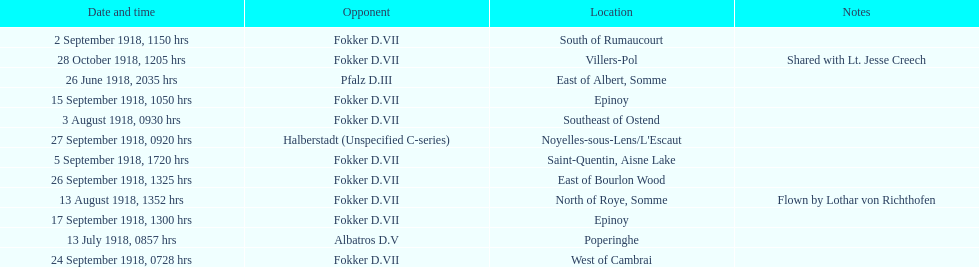Which opponent did kindley have the most victories against? Fokker D.VII. 